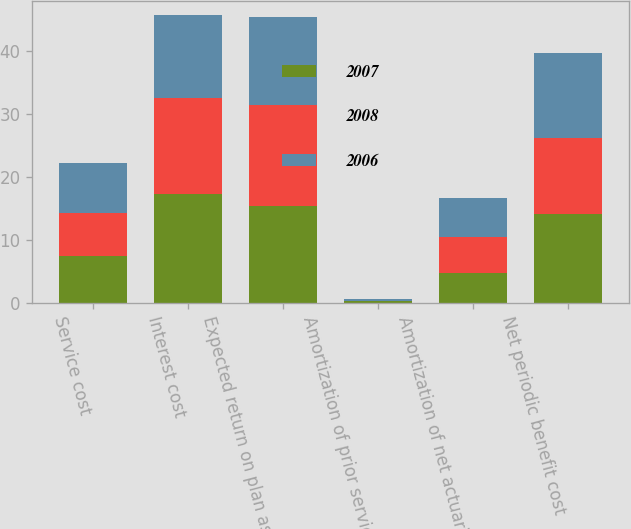<chart> <loc_0><loc_0><loc_500><loc_500><stacked_bar_chart><ecel><fcel>Service cost<fcel>Interest cost<fcel>Expected return on plan assets<fcel>Amortization of prior service<fcel>Amortization of net actuarial<fcel>Net periodic benefit cost<nl><fcel>2007<fcel>7.4<fcel>17.2<fcel>15.4<fcel>0.2<fcel>4.7<fcel>14.1<nl><fcel>2008<fcel>6.9<fcel>15.3<fcel>16<fcel>0.1<fcel>5.8<fcel>12.1<nl><fcel>2006<fcel>7.9<fcel>13.2<fcel>14<fcel>0.2<fcel>6.2<fcel>13.5<nl></chart> 